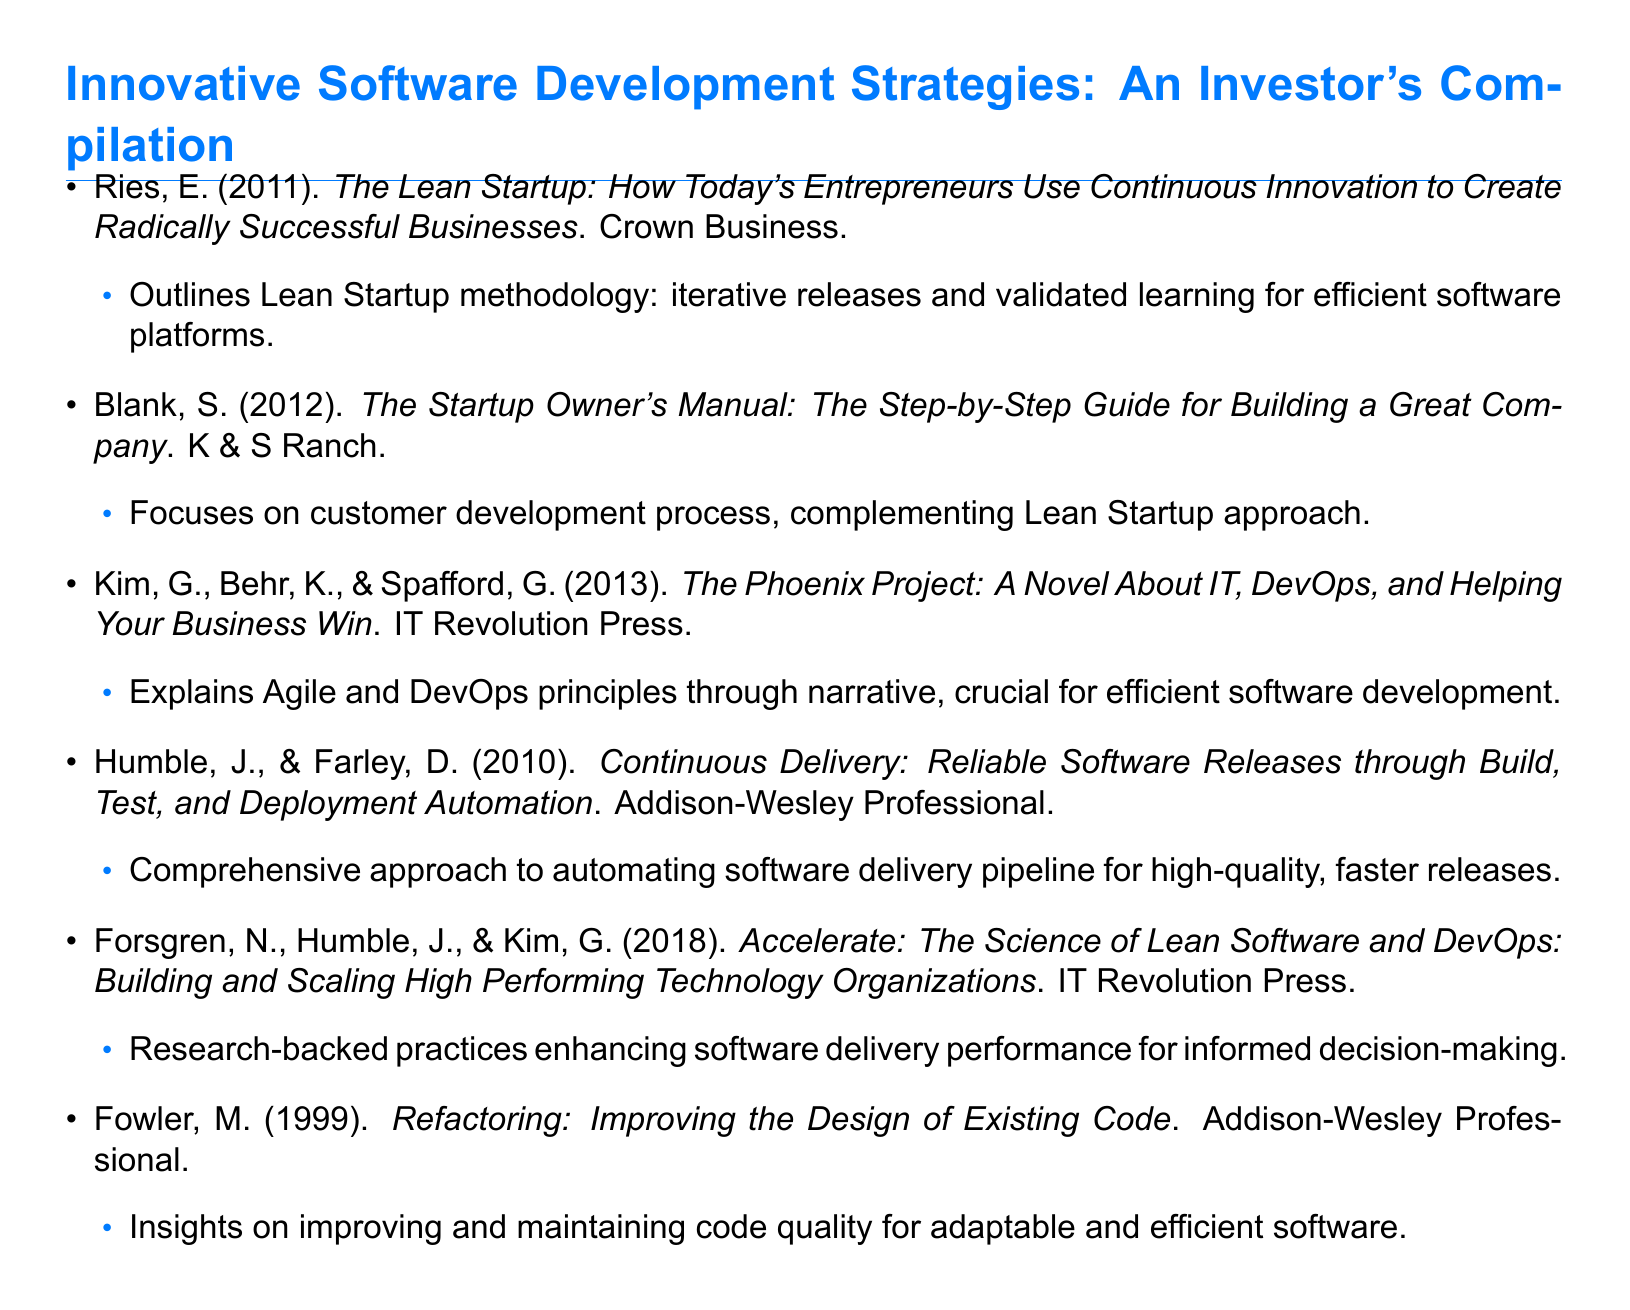What is the title of the first book listed? The first book listed is "The Lean Startup: How Today's Entrepreneurs Use Continuous Innovation to Create Radically Successful Businesses."
Answer: The Lean Startup Who is the author of the book "Accelerate"? The authors of "Accelerate" are Forsgren, Humble, and Kim.
Answer: Forsgren, Humble, and Kim In what year was "Continuous Delivery" published? "Continuous Delivery" was published in 2010.
Answer: 2010 What methodology does Eric Ries outline in his book? Eric Ries outlines the Lean Startup methodology in his book.
Answer: Lean Startup methodology Which book focuses on the customer development process? The book that focuses on the customer development process is "The Startup Owner's Manual."
Answer: The Startup Owner's Manual How many authors contributed to "The Phoenix Project"? There are three authors who contributed to "The Phoenix Project."
Answer: Three What color is used in the section titles of the document? The color used in the section titles is techblue.
Answer: techblue What is the main topic of "Refactoring"? The main topic of "Refactoring" is improving the design of existing code.
Answer: Improving the design of existing code 